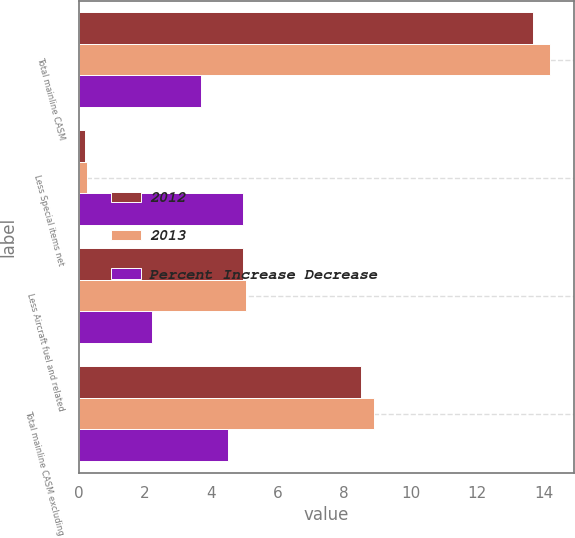Convert chart to OTSL. <chart><loc_0><loc_0><loc_500><loc_500><stacked_bar_chart><ecel><fcel>Total mainline CASM<fcel>Less Special items net<fcel>Less Aircraft fuel and related<fcel>Total mainline CASM excluding<nl><fcel>2012<fcel>13.67<fcel>0.18<fcel>4.94<fcel>8.5<nl><fcel>2013<fcel>14.2<fcel>0.25<fcel>5.05<fcel>8.9<nl><fcel>Percent Increase Decrease<fcel>3.7<fcel>4.94<fcel>2.2<fcel>4.5<nl></chart> 